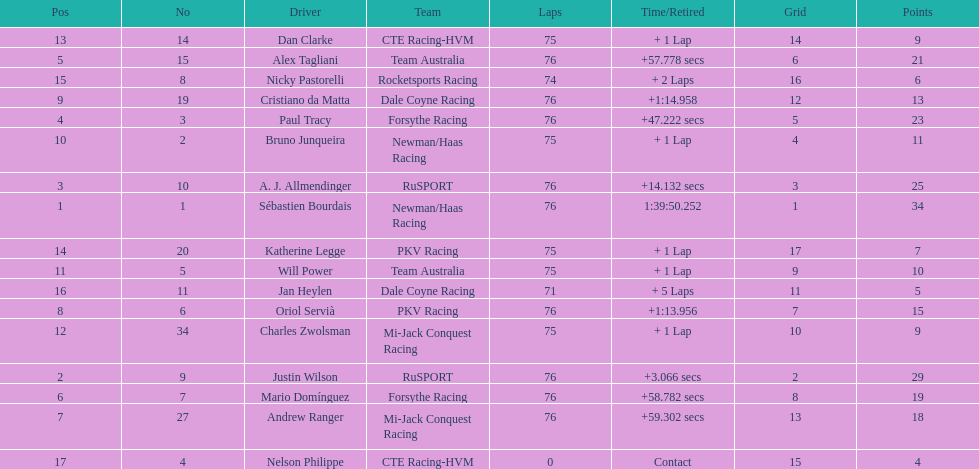Which canadian driver finished first: alex tagliani or paul tracy? Paul Tracy. Could you parse the entire table as a dict? {'header': ['Pos', 'No', 'Driver', 'Team', 'Laps', 'Time/Retired', 'Grid', 'Points'], 'rows': [['13', '14', 'Dan Clarke', 'CTE Racing-HVM', '75', '+ 1 Lap', '14', '9'], ['5', '15', 'Alex Tagliani', 'Team Australia', '76', '+57.778 secs', '6', '21'], ['15', '8', 'Nicky Pastorelli', 'Rocketsports Racing', '74', '+ 2 Laps', '16', '6'], ['9', '19', 'Cristiano da Matta', 'Dale Coyne Racing', '76', '+1:14.958', '12', '13'], ['4', '3', 'Paul Tracy', 'Forsythe Racing', '76', '+47.222 secs', '5', '23'], ['10', '2', 'Bruno Junqueira', 'Newman/Haas Racing', '75', '+ 1 Lap', '4', '11'], ['3', '10', 'A. J. Allmendinger', 'RuSPORT', '76', '+14.132 secs', '3', '25'], ['1', '1', 'Sébastien Bourdais', 'Newman/Haas Racing', '76', '1:39:50.252', '1', '34'], ['14', '20', 'Katherine Legge', 'PKV Racing', '75', '+ 1 Lap', '17', '7'], ['11', '5', 'Will Power', 'Team Australia', '75', '+ 1 Lap', '9', '10'], ['16', '11', 'Jan Heylen', 'Dale Coyne Racing', '71', '+ 5 Laps', '11', '5'], ['8', '6', 'Oriol Servià', 'PKV Racing', '76', '+1:13.956', '7', '15'], ['12', '34', 'Charles Zwolsman', 'Mi-Jack Conquest Racing', '75', '+ 1 Lap', '10', '9'], ['2', '9', 'Justin Wilson', 'RuSPORT', '76', '+3.066 secs', '2', '29'], ['6', '7', 'Mario Domínguez', 'Forsythe Racing', '76', '+58.782 secs', '8', '19'], ['7', '27', 'Andrew Ranger', 'Mi-Jack Conquest Racing', '76', '+59.302 secs', '13', '18'], ['17', '4', 'Nelson Philippe', 'CTE Racing-HVM', '0', 'Contact', '15', '4']]} 